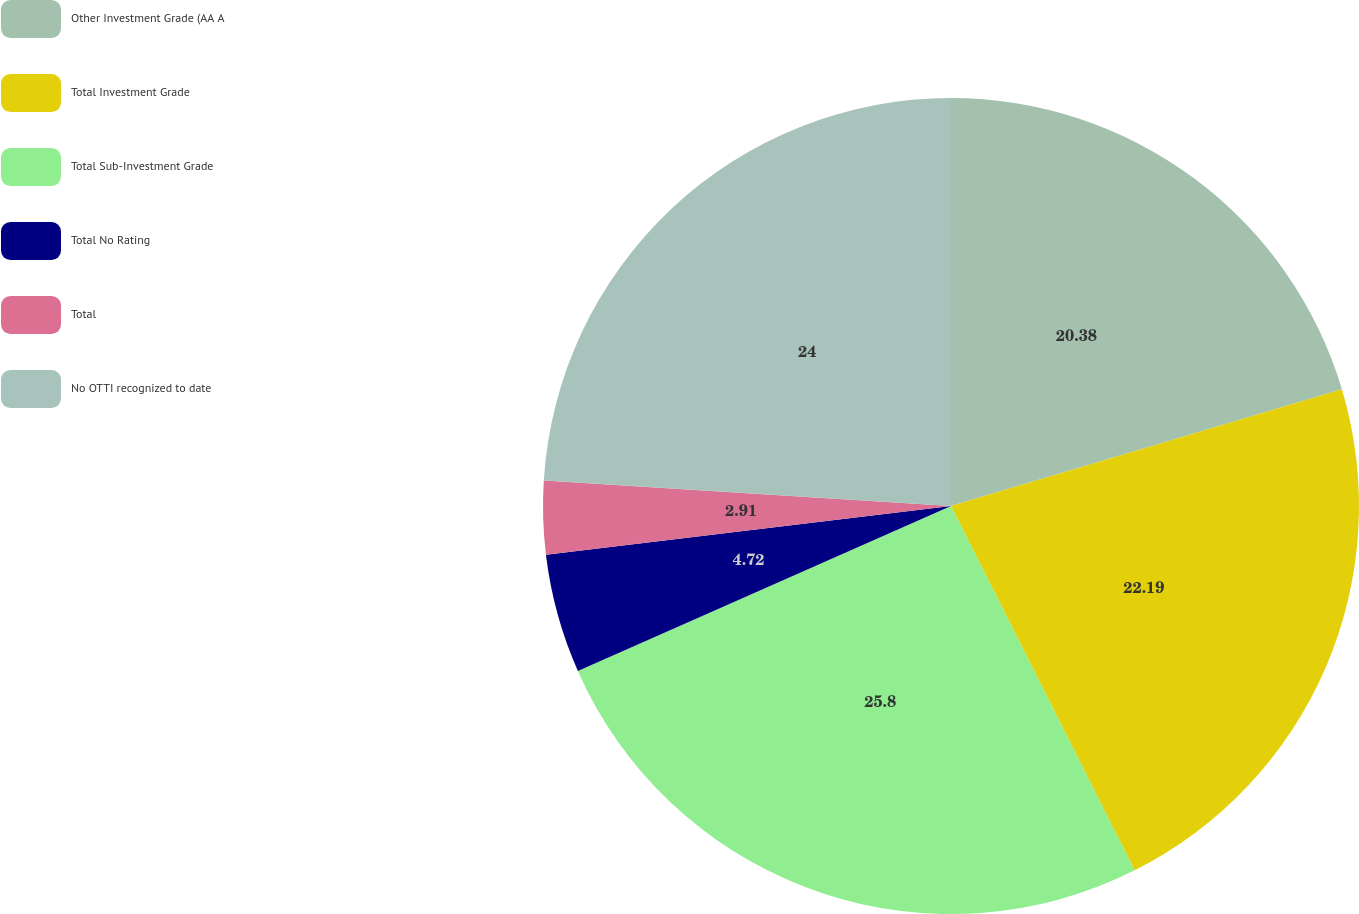Convert chart. <chart><loc_0><loc_0><loc_500><loc_500><pie_chart><fcel>Other Investment Grade (AA A<fcel>Total Investment Grade<fcel>Total Sub-Investment Grade<fcel>Total No Rating<fcel>Total<fcel>No OTTI recognized to date<nl><fcel>20.38%<fcel>22.19%<fcel>25.8%<fcel>4.72%<fcel>2.91%<fcel>24.0%<nl></chart> 